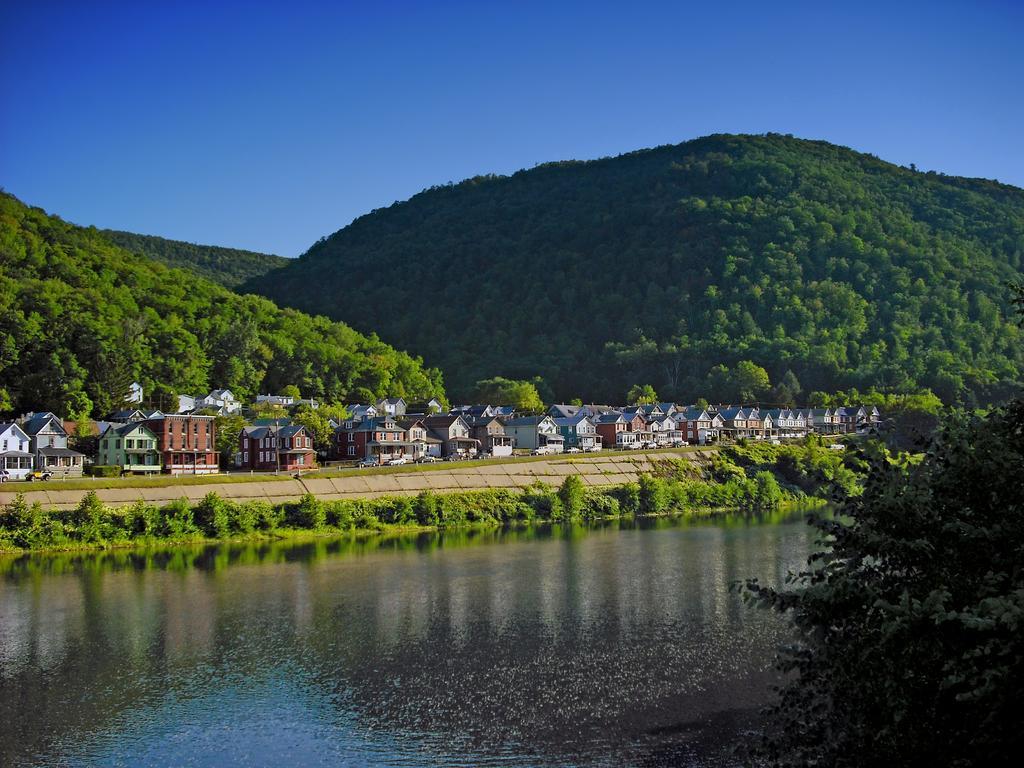Could you give a brief overview of what you see in this image? In this image, we can see a lake. There are some plants, buildings and hills in the middle of the image. There is a branch in the bottom right of the image. There is a sky at the top of the image. 